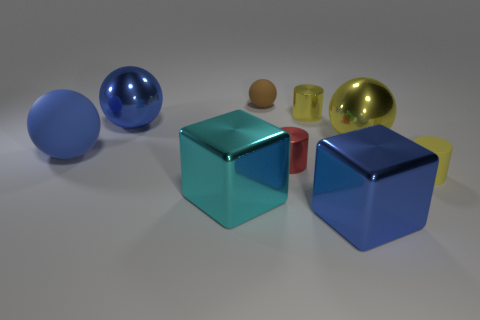Are there any other objects made of the same material as the tiny red thing?
Your response must be concise. Yes. What is the big cube that is right of the cyan metallic cube made of?
Your answer should be compact. Metal. Is the color of the small metal cylinder that is behind the blue rubber ball the same as the sphere to the left of the blue shiny sphere?
Offer a terse response. No. The matte object that is the same size as the cyan metallic block is what color?
Provide a short and direct response. Blue. What number of other objects are there of the same shape as the red object?
Your answer should be compact. 2. What size is the metallic cube to the left of the brown matte sphere?
Keep it short and to the point. Large. There is a shiny block to the left of the small yellow metallic cylinder; what number of large metallic things are to the right of it?
Provide a succinct answer. 2. What number of other things are the same size as the yellow metallic sphere?
Your answer should be compact. 4. Is the tiny ball the same color as the matte cylinder?
Your answer should be very brief. No. There is a blue matte thing that is in front of the big yellow ball; is its shape the same as the red thing?
Your response must be concise. No. 